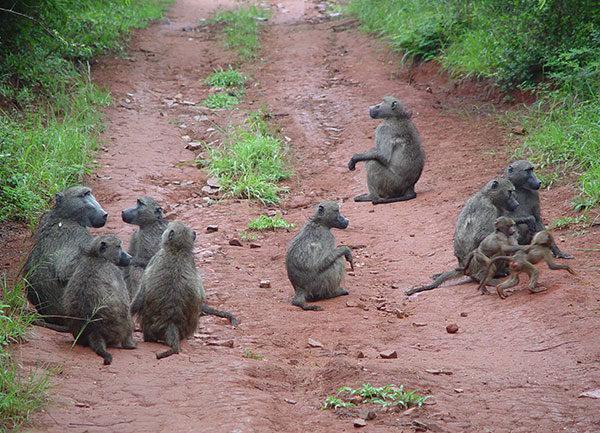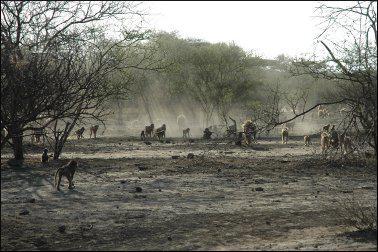The first image is the image on the left, the second image is the image on the right. Considering the images on both sides, is "An image shows baboons on a dirt path flanked by greenery." valid? Answer yes or no. Yes. The first image is the image on the left, the second image is the image on the right. Assess this claim about the two images: "Several primates are situated on a dirt roadway.". Correct or not? Answer yes or no. Yes. 